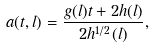<formula> <loc_0><loc_0><loc_500><loc_500>a ( t , l ) = \frac { g ( l ) t + 2 h ( l ) } { 2 h ^ { 1 / 2 } ( l ) } ,</formula> 